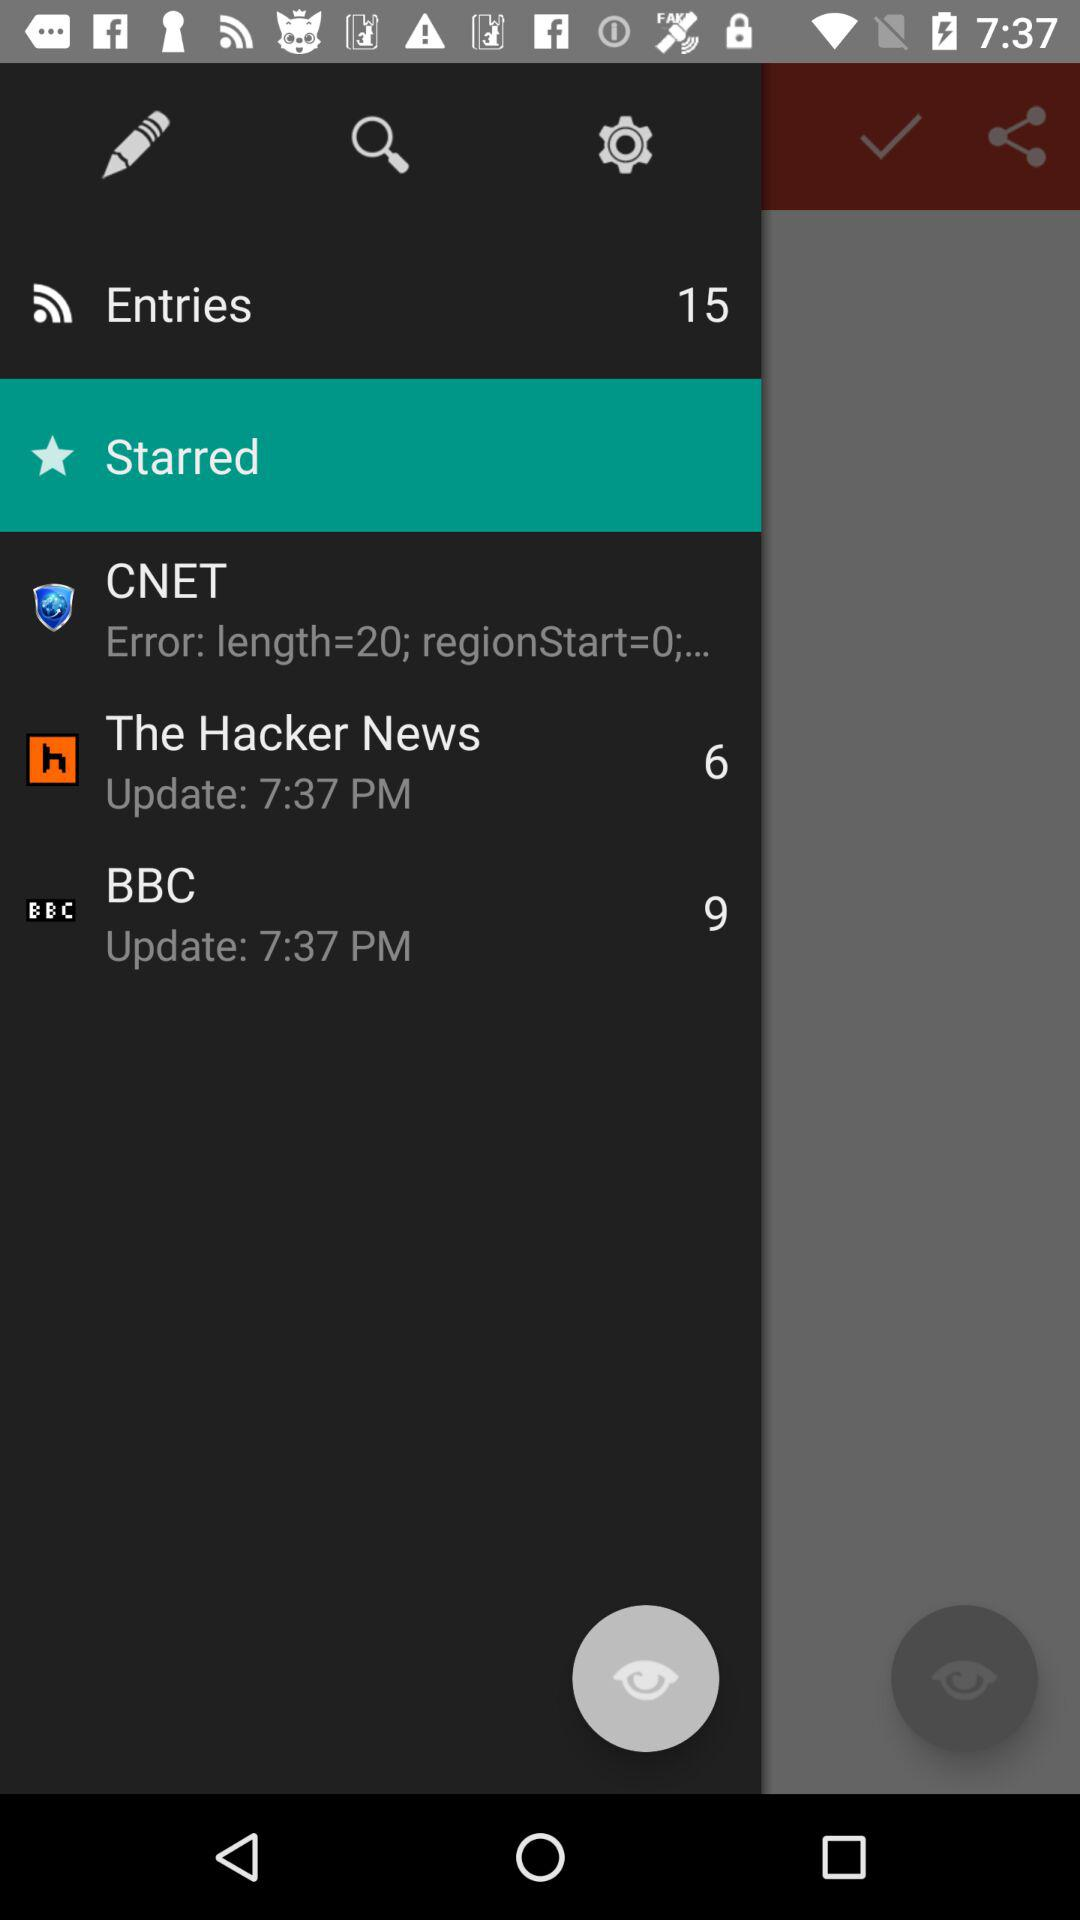What is the update time for "BBC"? The update time for "BBC" is 7:37 PM. 